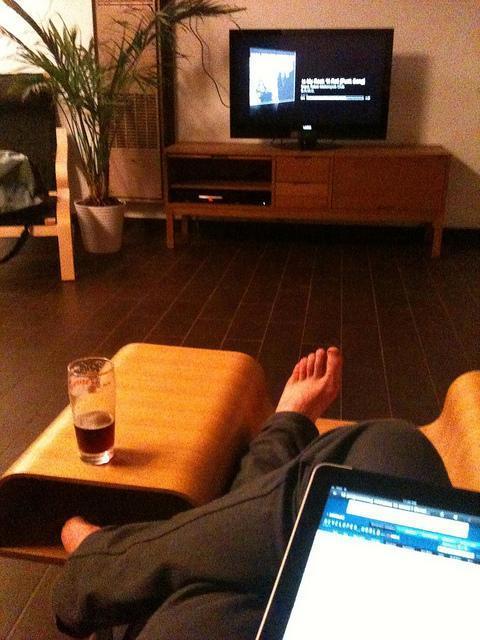How many screens are visible?
Give a very brief answer. 2. How many couches can be seen?
Give a very brief answer. 2. How many tvs are there?
Give a very brief answer. 2. How many circle donuts are there?
Give a very brief answer. 0. 